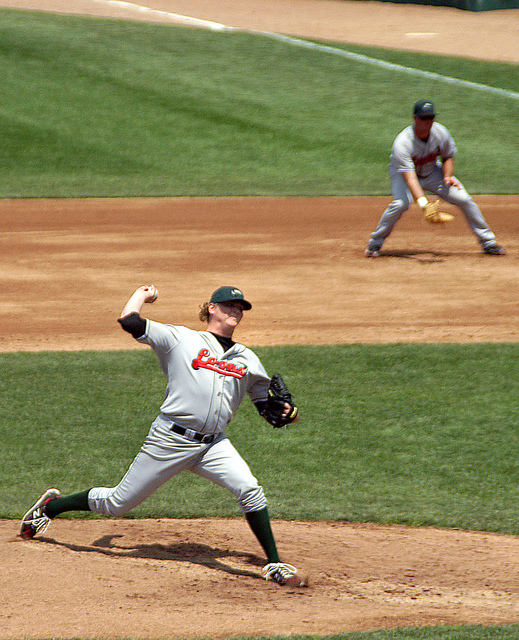<image>What team is this? I don't know what team this is. It could be 'loves', 'locals', 'logos', 'braves', 'lions', or 'dodgers'. What team is this? It is ambiguous what team this is. It can be seen as 'locals', 'logos', or 'braves'. 